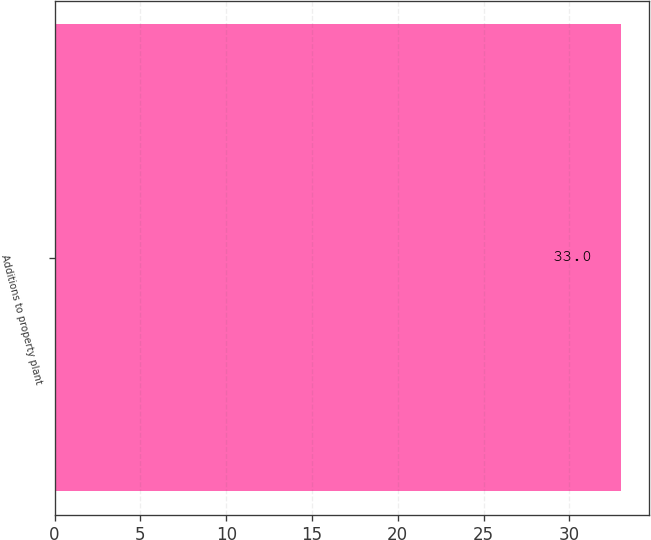Convert chart. <chart><loc_0><loc_0><loc_500><loc_500><bar_chart><fcel>Additions to property plant<nl><fcel>33<nl></chart> 